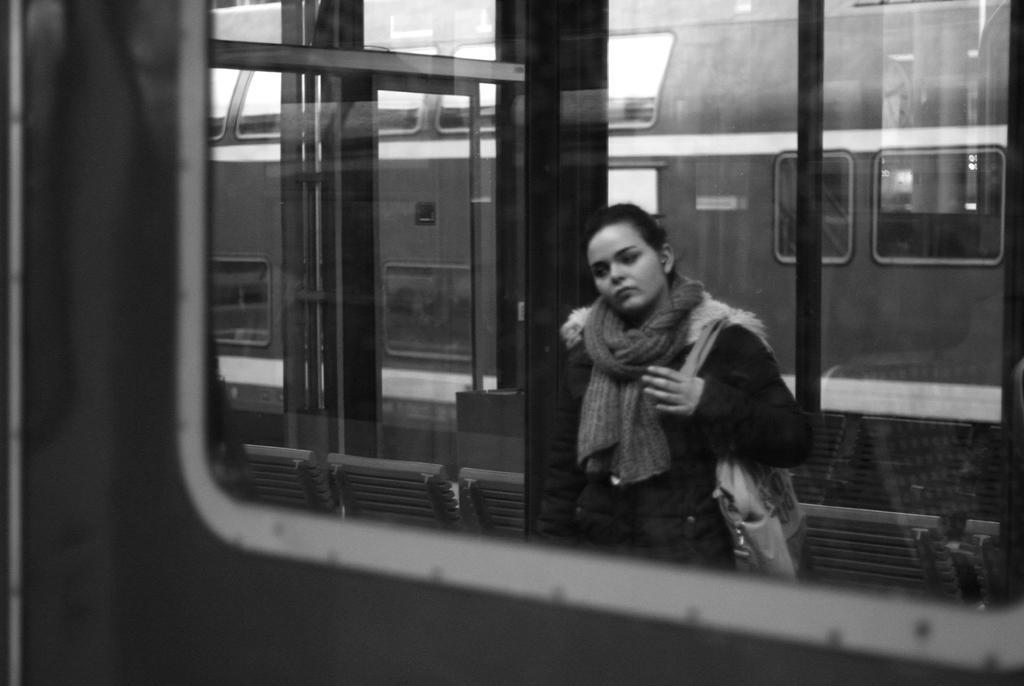How would you summarize this image in a sentence or two? In this image we can see a train. There are few chairs in the image. A person is wearing a handbag on her shoulder. There are some reflections on the glasses. 